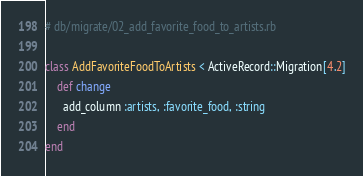Convert code to text. <code><loc_0><loc_0><loc_500><loc_500><_Ruby_># db/migrate/02_add_favorite_food_to_artists.rb

class AddFavoriteFoodToArtists < ActiveRecord::Migration[4.2]
    def change
      add_column :artists, :favorite_food, :string
    end
end</code> 